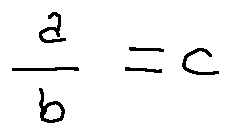Convert formula to latex. <formula><loc_0><loc_0><loc_500><loc_500>\frac { a } { b } = c</formula> 